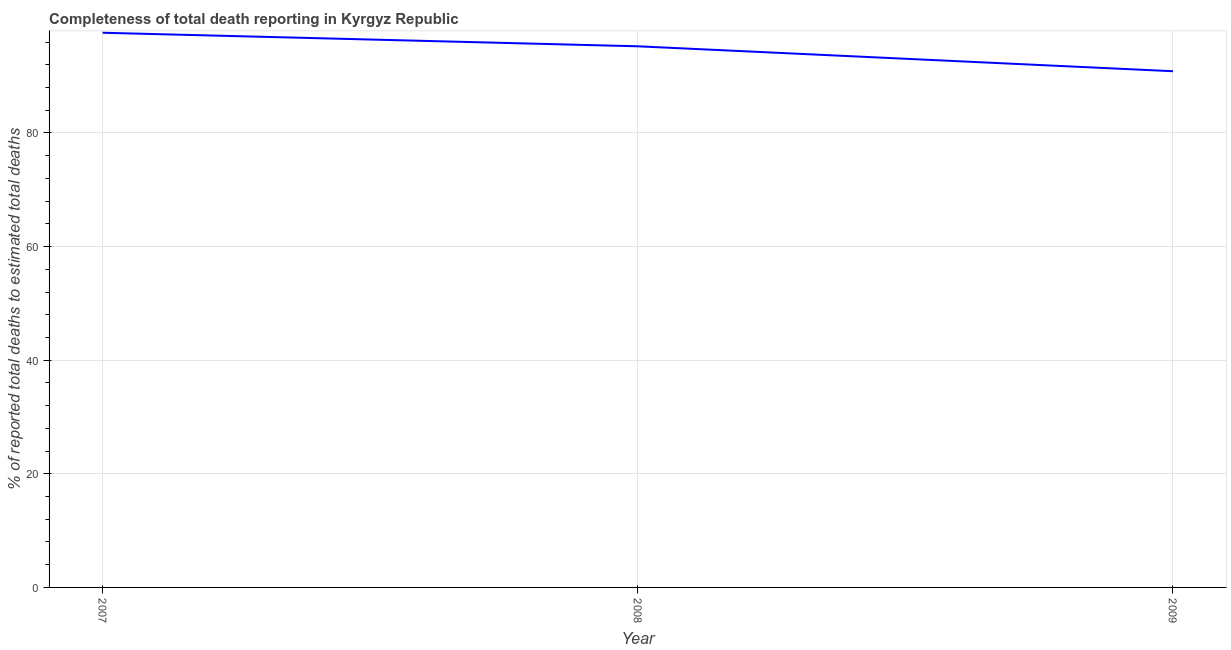What is the completeness of total death reports in 2008?
Make the answer very short. 95.26. Across all years, what is the maximum completeness of total death reports?
Provide a succinct answer. 97.65. Across all years, what is the minimum completeness of total death reports?
Provide a short and direct response. 90.87. What is the sum of the completeness of total death reports?
Provide a succinct answer. 283.79. What is the difference between the completeness of total death reports in 2008 and 2009?
Your answer should be very brief. 4.39. What is the average completeness of total death reports per year?
Ensure brevity in your answer.  94.6. What is the median completeness of total death reports?
Give a very brief answer. 95.26. In how many years, is the completeness of total death reports greater than 4 %?
Your response must be concise. 3. What is the ratio of the completeness of total death reports in 2007 to that in 2009?
Keep it short and to the point. 1.07. Is the difference between the completeness of total death reports in 2008 and 2009 greater than the difference between any two years?
Your answer should be very brief. No. What is the difference between the highest and the second highest completeness of total death reports?
Provide a succinct answer. 2.38. Is the sum of the completeness of total death reports in 2007 and 2009 greater than the maximum completeness of total death reports across all years?
Provide a succinct answer. Yes. What is the difference between the highest and the lowest completeness of total death reports?
Provide a short and direct response. 6.77. In how many years, is the completeness of total death reports greater than the average completeness of total death reports taken over all years?
Provide a succinct answer. 2. How many lines are there?
Provide a succinct answer. 1. What is the difference between two consecutive major ticks on the Y-axis?
Keep it short and to the point. 20. Does the graph contain any zero values?
Your answer should be very brief. No. What is the title of the graph?
Your answer should be very brief. Completeness of total death reporting in Kyrgyz Republic. What is the label or title of the Y-axis?
Give a very brief answer. % of reported total deaths to estimated total deaths. What is the % of reported total deaths to estimated total deaths of 2007?
Provide a short and direct response. 97.65. What is the % of reported total deaths to estimated total deaths in 2008?
Give a very brief answer. 95.26. What is the % of reported total deaths to estimated total deaths in 2009?
Give a very brief answer. 90.87. What is the difference between the % of reported total deaths to estimated total deaths in 2007 and 2008?
Make the answer very short. 2.38. What is the difference between the % of reported total deaths to estimated total deaths in 2007 and 2009?
Make the answer very short. 6.77. What is the difference between the % of reported total deaths to estimated total deaths in 2008 and 2009?
Give a very brief answer. 4.39. What is the ratio of the % of reported total deaths to estimated total deaths in 2007 to that in 2009?
Your response must be concise. 1.07. What is the ratio of the % of reported total deaths to estimated total deaths in 2008 to that in 2009?
Ensure brevity in your answer.  1.05. 